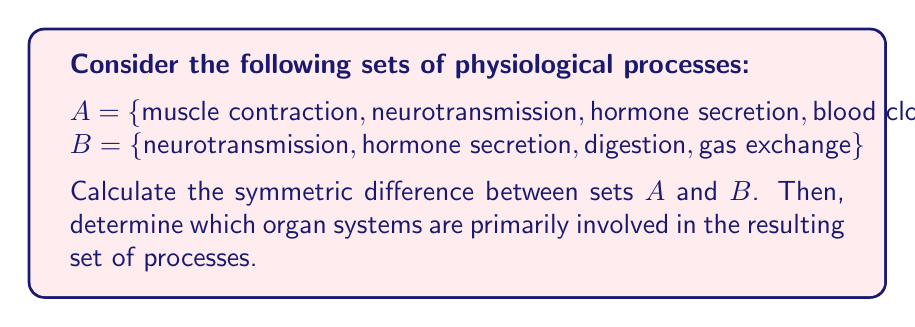Solve this math problem. 1. Recall that the symmetric difference between two sets A and B, denoted as $A \triangle B$, is defined as:

   $A \triangle B = (A \setminus B) \cup (B \setminus A)$

2. First, let's find $A \setminus B$:
   A \ B = {muscle contraction, blood clotting}

3. Next, let's find $B \setminus A$:
   B \ A = {digestion, gas exchange}

4. Now, we can unite these two sets to get the symmetric difference:
   $A \triangle B = \{muscle contraction, blood clotting, digestion, gas exchange\}$

5. Analyzing the resulting processes and their associated organ systems:
   - Muscle contraction: Muscular system
   - Blood clotting: Cardiovascular system
   - Digestion: Digestive system
   - Gas exchange: Respiratory system

Therefore, the symmetric difference includes processes from the muscular, cardiovascular, digestive, and respiratory systems.
Answer: $A \triangle B = \{muscle contraction, blood clotting, digestion, gas exchange\}$; Muscular, cardiovascular, digestive, and respiratory systems 